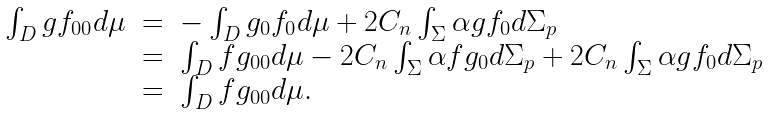<formula> <loc_0><loc_0><loc_500><loc_500>\begin{array} { c c l } \int _ { D } g f _ { 0 0 } d \mu & = & - \int _ { D } g _ { 0 } f _ { 0 } d \mu + 2 C _ { n } \int _ { \Sigma } \alpha g f _ { 0 } d \Sigma _ { p } \\ & = & \int _ { D } f g _ { 0 0 } d \mu - 2 C _ { n } \int _ { \Sigma } \alpha f g _ { 0 } d \Sigma _ { p } + 2 C _ { n } \int _ { \Sigma } \alpha g f _ { 0 } d \Sigma _ { p } \\ & = & \int _ { D } f g _ { 0 0 } d \mu . \end{array}</formula> 